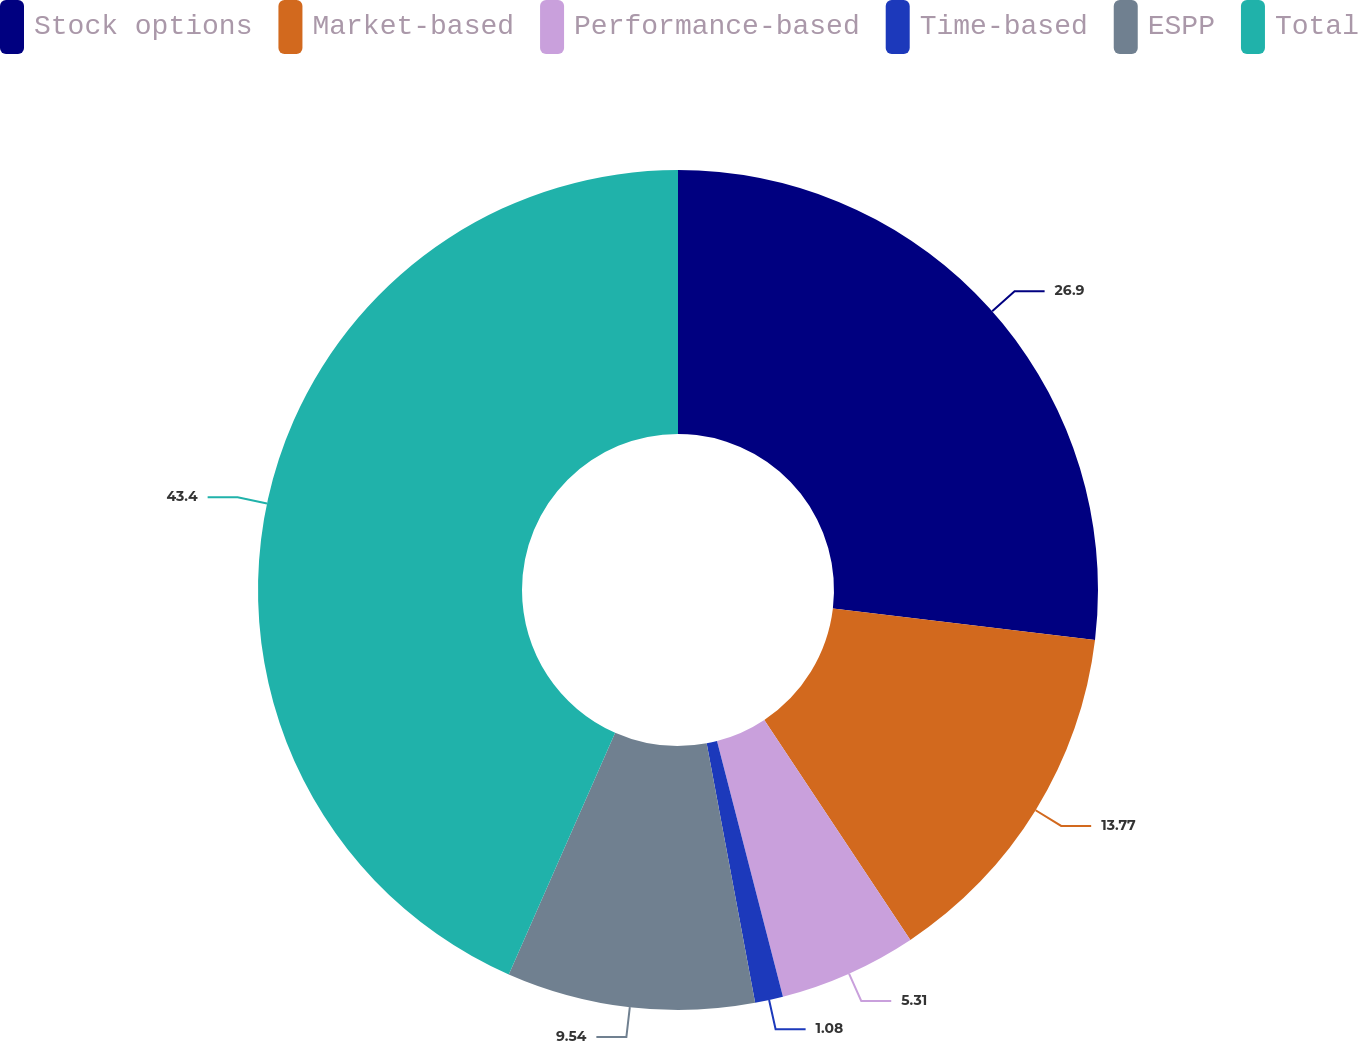Convert chart to OTSL. <chart><loc_0><loc_0><loc_500><loc_500><pie_chart><fcel>Stock options<fcel>Market-based<fcel>Performance-based<fcel>Time-based<fcel>ESPP<fcel>Total<nl><fcel>26.9%<fcel>13.77%<fcel>5.31%<fcel>1.08%<fcel>9.54%<fcel>43.4%<nl></chart> 